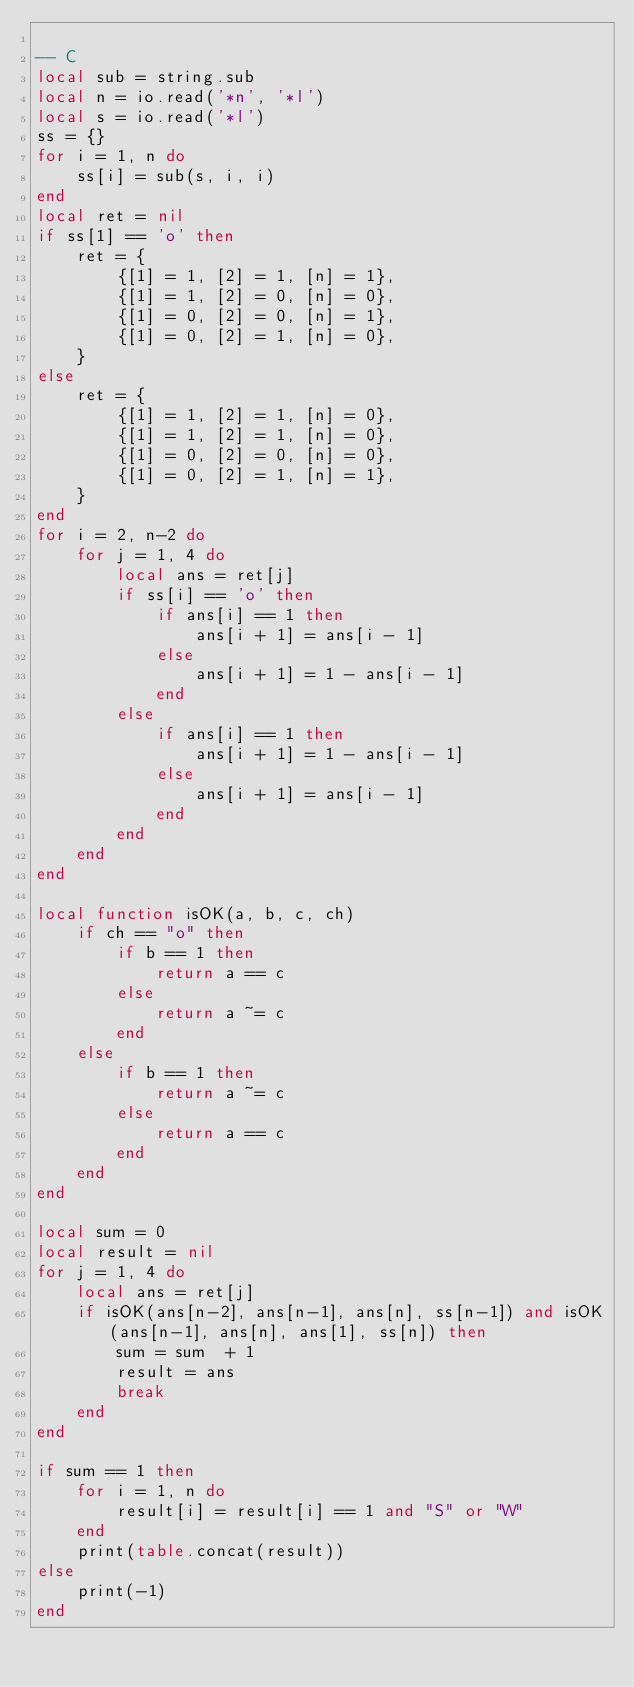<code> <loc_0><loc_0><loc_500><loc_500><_Lua_>
-- C
local sub = string.sub
local n = io.read('*n', '*l')
local s = io.read('*l')
ss = {}
for i = 1, n do
	ss[i] = sub(s, i, i)
end
local ret = nil
if ss[1] == 'o' then
	ret = {
		{[1] = 1, [2] = 1, [n] = 1},
		{[1] = 1, [2] = 0, [n] = 0},
		{[1] = 0, [2] = 0, [n] = 1},
		{[1] = 0, [2] = 1, [n] = 0},
	}
else
	ret = {
		{[1] = 1, [2] = 1, [n] = 0},
		{[1] = 1, [2] = 1, [n] = 0},
		{[1] = 0, [2] = 0, [n] = 0},
		{[1] = 0, [2] = 1, [n] = 1},
	}
end
for i = 2, n-2 do
	for j = 1, 4 do
		local ans = ret[j]
		if ss[i] == 'o' then
			if ans[i] == 1 then
				ans[i + 1] = ans[i - 1]
			else
				ans[i + 1] = 1 - ans[i - 1]
			end
		else
			if ans[i] == 1 then
				ans[i + 1] = 1 - ans[i - 1]
			else
				ans[i + 1] = ans[i - 1]
			end
		end
	end
end

local function isOK(a, b, c, ch)
	if ch == "o" then
		if b == 1 then
			return a == c
		else
			return a ~= c
		end
	else
		if b == 1 then
			return a ~= c
		else
			return a == c
		end
	end
end

local sum = 0
local result = nil
for j = 1, 4 do
	local ans = ret[j]
	if isOK(ans[n-2], ans[n-1], ans[n], ss[n-1]) and isOK(ans[n-1], ans[n], ans[1], ss[n]) then
		sum = sum  + 1
		result = ans
		break
	end
end

if sum == 1 then
	for i = 1, n do
		result[i] = result[i] == 1 and "S" or "W"
	end
	print(table.concat(result))
else
	print(-1)
end</code> 